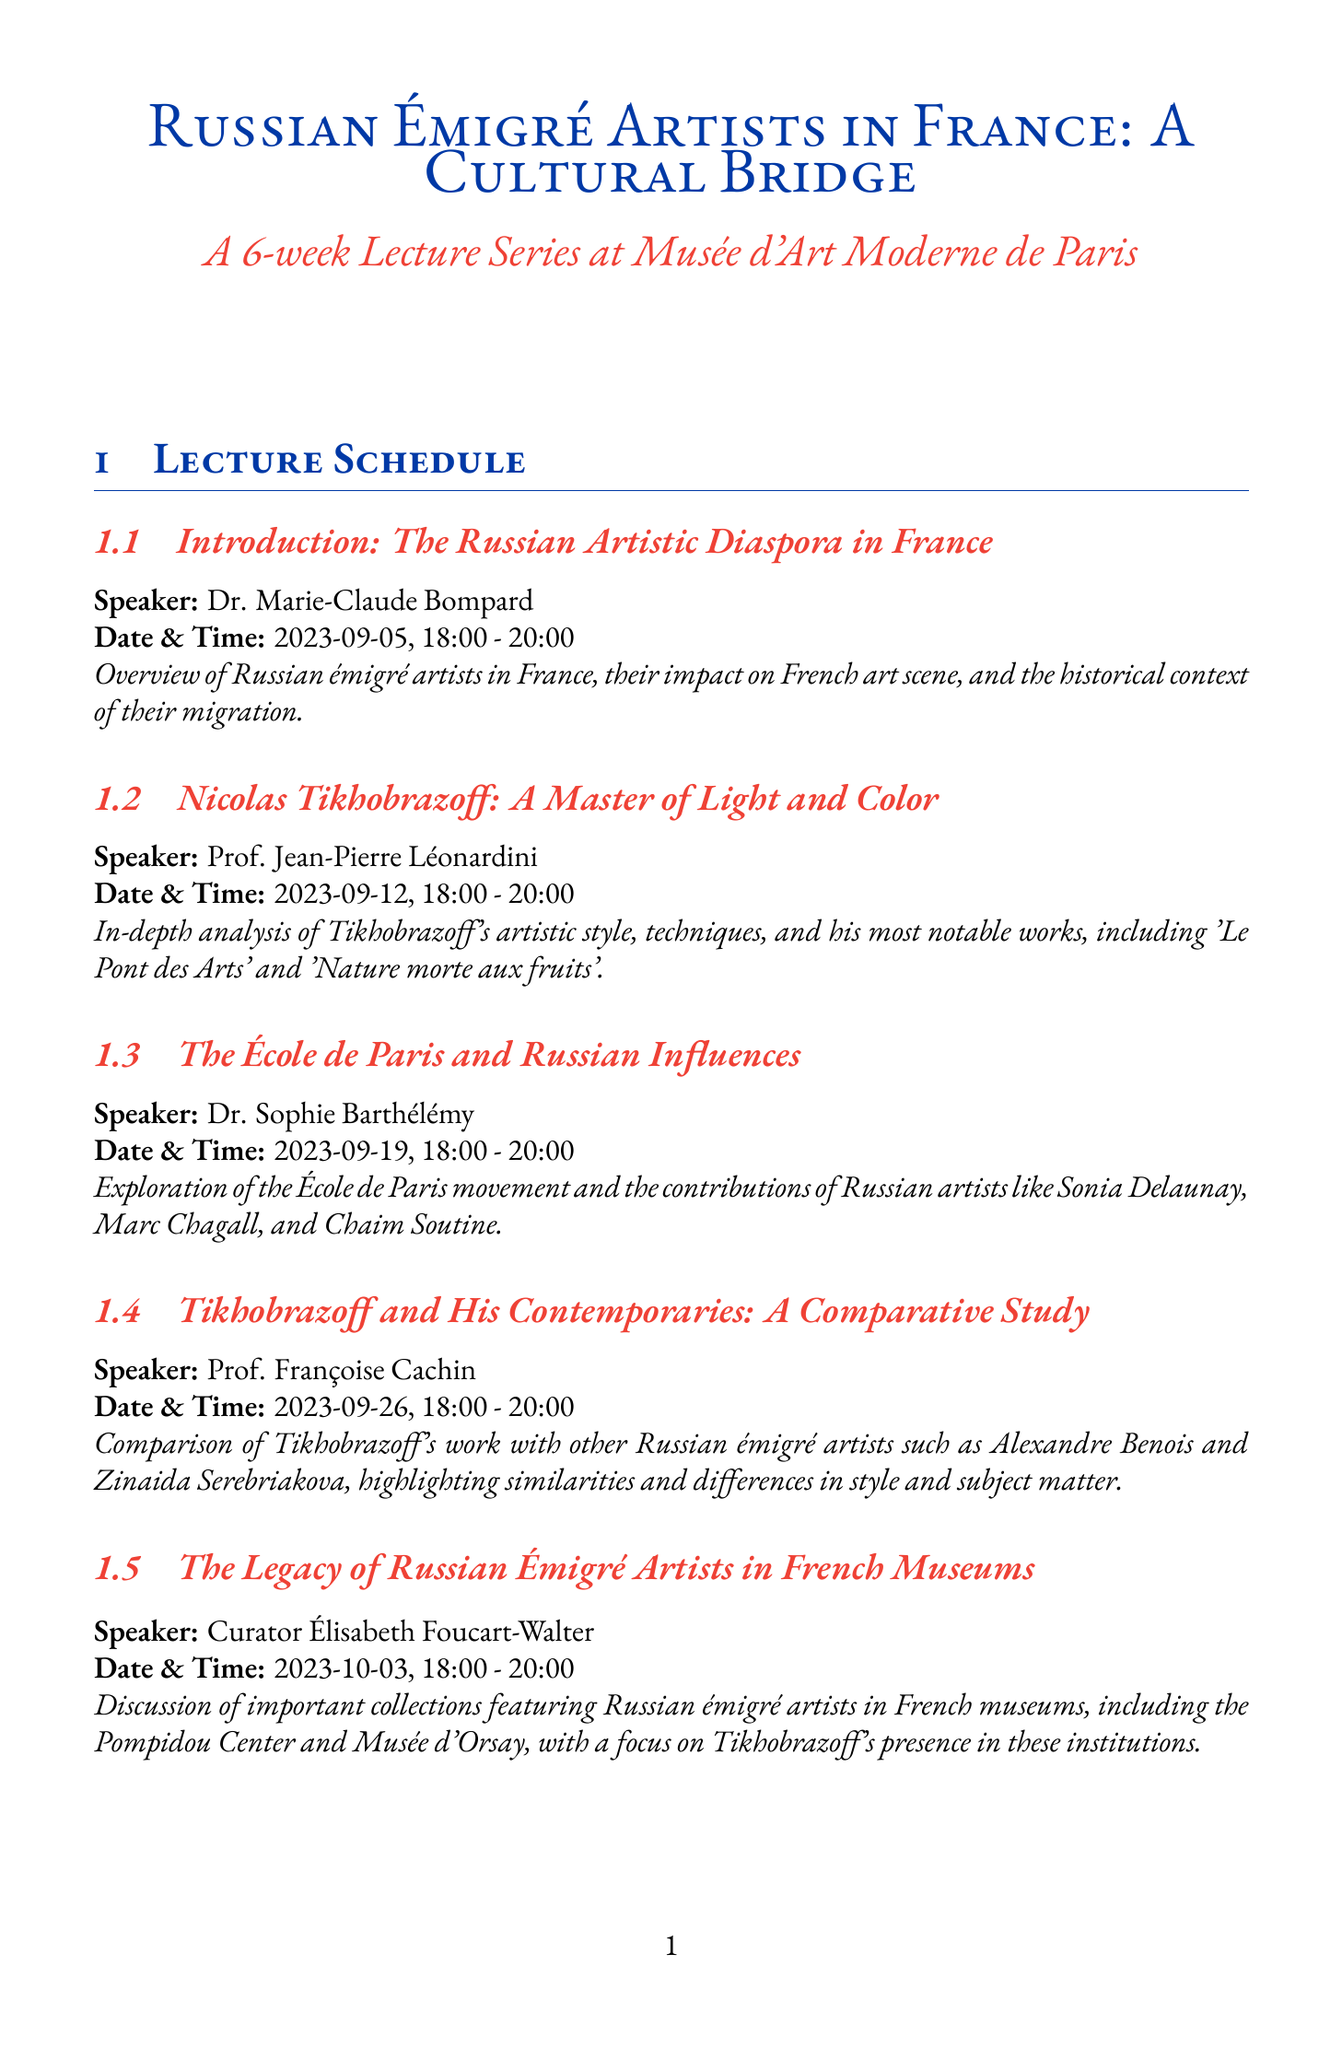What is the title of the lecture on September 12? The title is stated in the schedule as "Nicolas Tikhobrazoff: A Master of Light and Color."
Answer: Nicolas Tikhobrazoff: A Master of Light and Color Who is the speaker for the lecture on September 19? The speaker's name is mentioned in the schedule for that date as Dr. Sophie Barthélémy.
Answer: Dr. Sophie Barthélémy What date is the guided tour of Tikhobrazoff's works? The date for the guided tour is clearly stated in the document as 2023-09-16.
Answer: 2023-09-16 How many weeks does the lecture series last? The duration of the lecture series is explicitly mentioned as 6 weeks.
Answer: 6 weeks What is a key feature of the workshop on September 30? The document states that it focuses on Tikhobrazoff's unique approach to color.
Answer: Tikhobrazoff's unique approach to color What is the main focus of the last lecture on October 10? The focus is noted in the schedule as the lasting impact of Russian émigré artists on contemporary French art.
Answer: Lasting impact on contemporary French art Where is the lecture series held? The location for the lectures is mentioned as Musée d'Art Moderne de Paris.
Answer: Musée d'Art Moderne de Paris Who authored the book "Nicolas Tikhobrazoff: Lumière et Couleur de Paris"? The author’s name is provided in the reading list as Nathalie Gontcharova.
Answer: Nathalie Gontcharova 